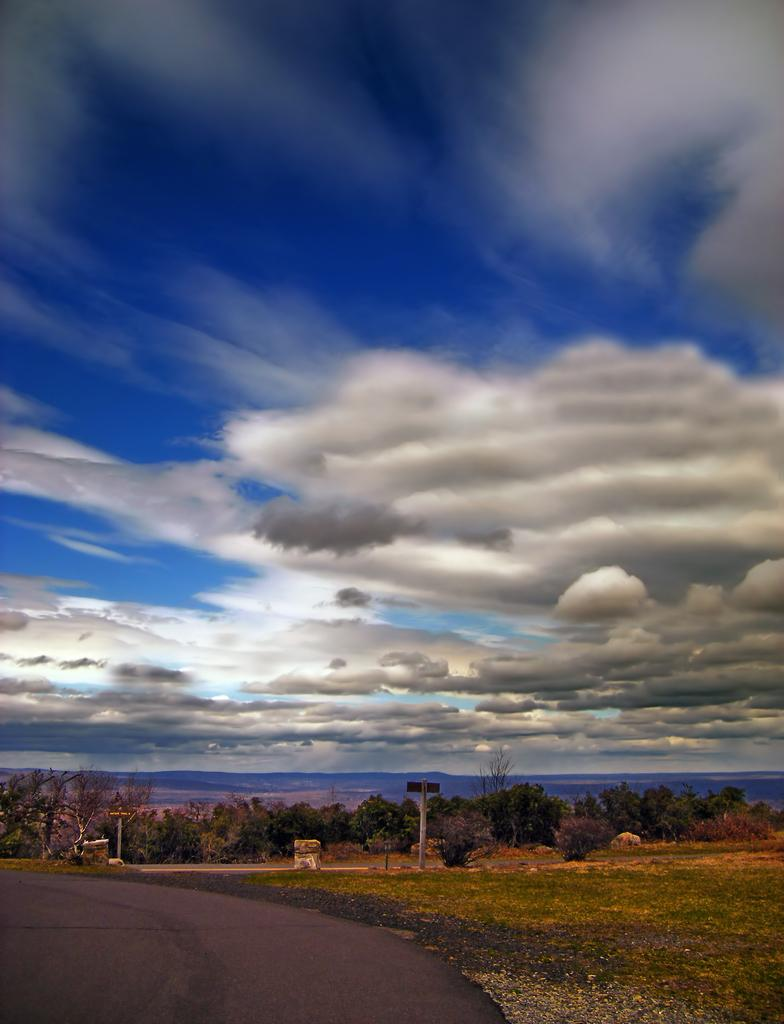What is the main feature of the image? There is a road in the image. What else can be seen along the road? There are poles visible in the image. What can be seen in the distance in the image? Trees are visible in the background of the image. How would you describe the weather in the image? The sky is cloudy in the background of the image. What type of instrument is being played by the person in the plantation in the image? There is no person or plantation present in the image; it only features a road, poles, trees, and a cloudy sky. 